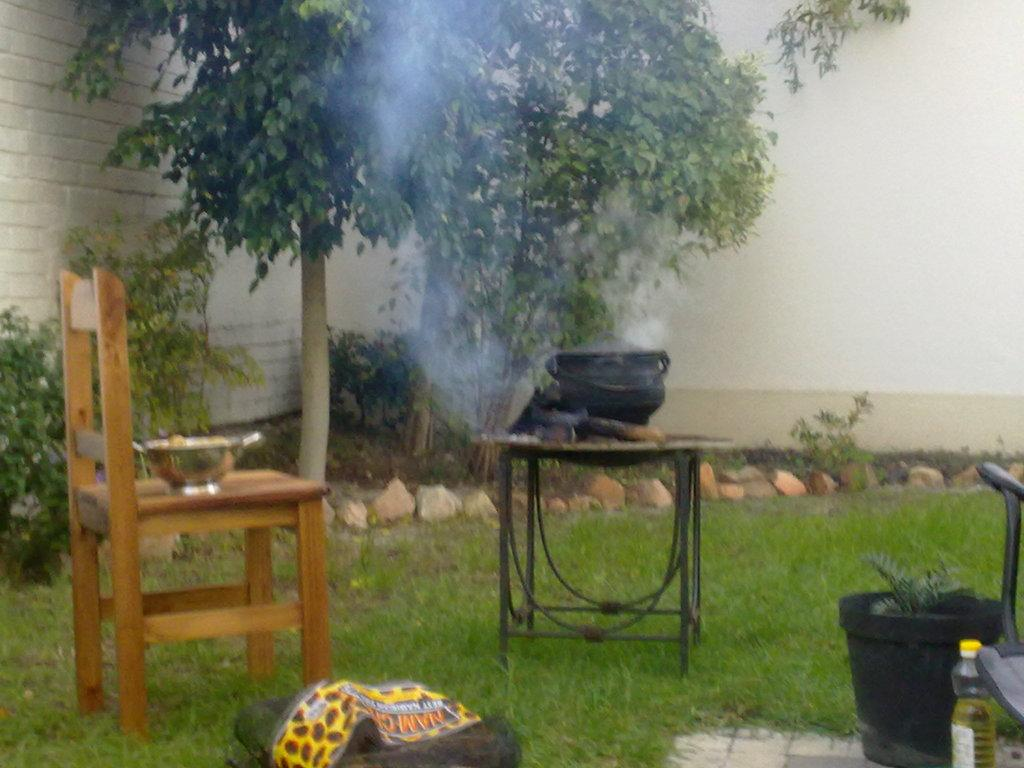What type of furniture is present in the image? There is a chair and a table in the image. What type of structure is visible in the background? There is a wall in the image. What type of vegetation is present in the image? There is a tree and a plant in the image. How is the plant being displayed in the image? The plant is in a pot in the image. What is placed on the chair in the image? There is a bowl on the chair in the image. What is placed on the table in the image? There is a container on the table in the image. What type of object is visible in the image? There is a bottle in the image. What type of letter is being written on the skin in the image? There is no letter or skin present in the image. How does the water flow through the image? There is no water present in the image. 